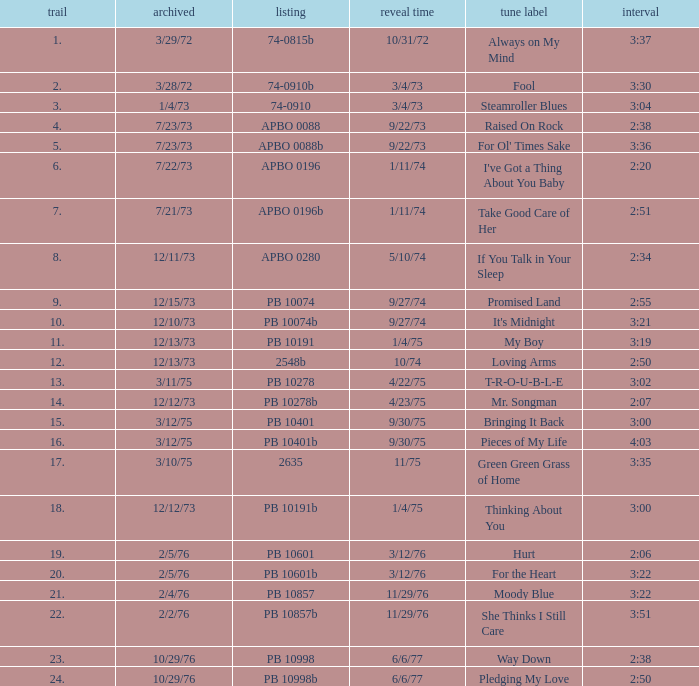Could you parse the entire table? {'header': ['trail', 'archived', 'listing', 'reveal time', 'tune label', 'interval'], 'rows': [['1.', '3/29/72', '74-0815b', '10/31/72', 'Always on My Mind', '3:37'], ['2.', '3/28/72', '74-0910b', '3/4/73', 'Fool', '3:30'], ['3.', '1/4/73', '74-0910', '3/4/73', 'Steamroller Blues', '3:04'], ['4.', '7/23/73', 'APBO 0088', '9/22/73', 'Raised On Rock', '2:38'], ['5.', '7/23/73', 'APBO 0088b', '9/22/73', "For Ol' Times Sake", '3:36'], ['6.', '7/22/73', 'APBO 0196', '1/11/74', "I've Got a Thing About You Baby", '2:20'], ['7.', '7/21/73', 'APBO 0196b', '1/11/74', 'Take Good Care of Her', '2:51'], ['8.', '12/11/73', 'APBO 0280', '5/10/74', 'If You Talk in Your Sleep', '2:34'], ['9.', '12/15/73', 'PB 10074', '9/27/74', 'Promised Land', '2:55'], ['10.', '12/10/73', 'PB 10074b', '9/27/74', "It's Midnight", '3:21'], ['11.', '12/13/73', 'PB 10191', '1/4/75', 'My Boy', '3:19'], ['12.', '12/13/73', '2548b', '10/74', 'Loving Arms', '2:50'], ['13.', '3/11/75', 'PB 10278', '4/22/75', 'T-R-O-U-B-L-E', '3:02'], ['14.', '12/12/73', 'PB 10278b', '4/23/75', 'Mr. Songman', '2:07'], ['15.', '3/12/75', 'PB 10401', '9/30/75', 'Bringing It Back', '3:00'], ['16.', '3/12/75', 'PB 10401b', '9/30/75', 'Pieces of My Life', '4:03'], ['17.', '3/10/75', '2635', '11/75', 'Green Green Grass of Home', '3:35'], ['18.', '12/12/73', 'PB 10191b', '1/4/75', 'Thinking About You', '3:00'], ['19.', '2/5/76', 'PB 10601', '3/12/76', 'Hurt', '2:06'], ['20.', '2/5/76', 'PB 10601b', '3/12/76', 'For the Heart', '3:22'], ['21.', '2/4/76', 'PB 10857', '11/29/76', 'Moody Blue', '3:22'], ['22.', '2/2/76', 'PB 10857b', '11/29/76', 'She Thinks I Still Care', '3:51'], ['23.', '10/29/76', 'PB 10998', '6/6/77', 'Way Down', '2:38'], ['24.', '10/29/76', 'PB 10998b', '6/6/77', 'Pledging My Love', '2:50']]} Tell me the time for 6/6/77 release date and song title of way down 2:38. 